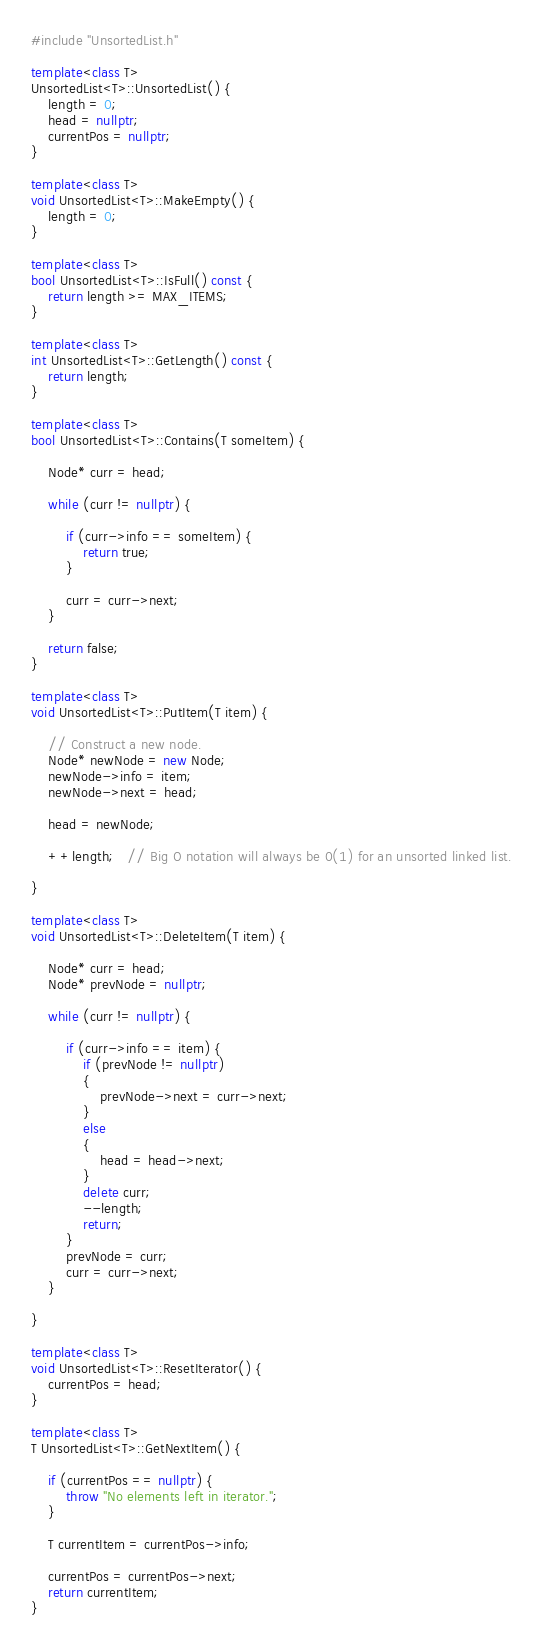Convert code to text. <code><loc_0><loc_0><loc_500><loc_500><_C++_>#include "UnsortedList.h"

template<class T>
UnsortedList<T>::UnsortedList() {
    length = 0;
    head = nullptr;
    currentPos = nullptr;
}

template<class T>
void UnsortedList<T>::MakeEmpty() {
    length = 0;
}

template<class T>
bool UnsortedList<T>::IsFull() const {
    return length >= MAX_ITEMS;
}

template<class T>
int UnsortedList<T>::GetLength() const {
    return length;
}

template<class T>
bool UnsortedList<T>::Contains(T someItem) {

    Node* curr = head;

    while (curr != nullptr) {

        if (curr->info == someItem) {
            return true;
        }

        curr = curr->next;
    }

    return false;
}

template<class T>
void UnsortedList<T>::PutItem(T item) {

    // Construct a new node.
    Node* newNode = new Node;
    newNode->info = item;
    newNode->next = head;

    head = newNode;

    ++length;   // Big O notation will always be 0(1) for an unsorted linked list.

}

template<class T>
void UnsortedList<T>::DeleteItem(T item) {

    Node* curr = head;
    Node* prevNode = nullptr;

    while (curr != nullptr) {

        if (curr->info == item) {
            if (prevNode != nullptr)
            {
                prevNode->next = curr->next;
            }
            else
            {
                head = head->next;
            }
            delete curr;
            --length;
            return;
        }
        prevNode = curr;
        curr = curr->next;
    }

}

template<class T>
void UnsortedList<T>::ResetIterator() {
    currentPos = head;
}

template<class T>
T UnsortedList<T>::GetNextItem() {

    if (currentPos == nullptr) {
        throw "No elements left in iterator.";
    }

    T currentItem = currentPos->info;

    currentPos = currentPos->next;
    return currentItem;
}
</code> 